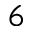<formula> <loc_0><loc_0><loc_500><loc_500>6</formula> 